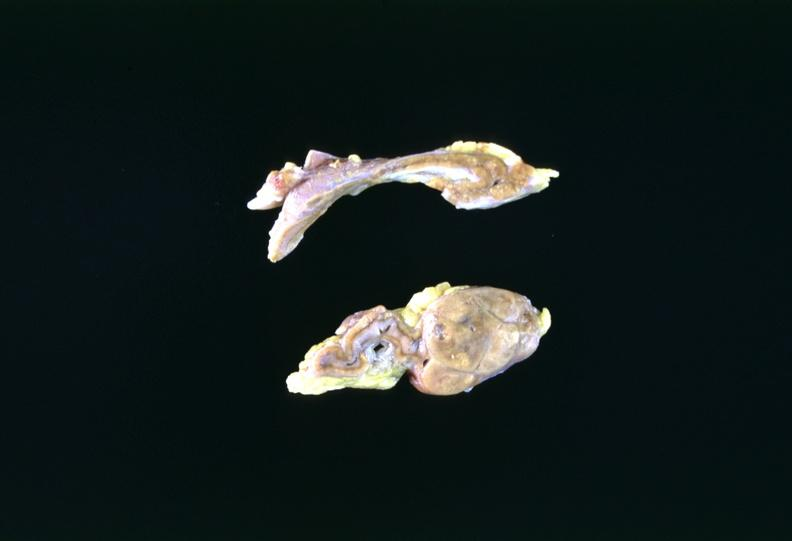s lateral view present?
Answer the question using a single word or phrase. No 